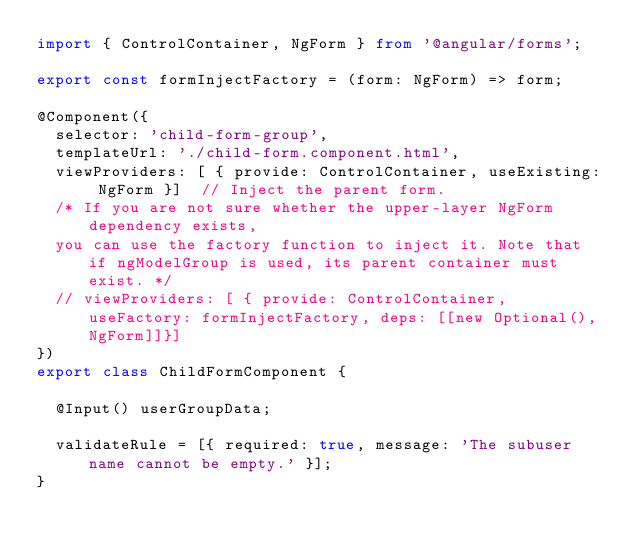<code> <loc_0><loc_0><loc_500><loc_500><_TypeScript_>import { ControlContainer, NgForm } from '@angular/forms';

export const formInjectFactory = (form: NgForm) => form;

@Component({
  selector: 'child-form-group',
  templateUrl: './child-form.component.html',
  viewProviders: [ { provide: ControlContainer, useExisting: NgForm }]  // Inject the parent form.
  /* If you are not sure whether the upper-layer NgForm dependency exists,
  you can use the factory function to inject it. Note that if ngModelGroup is used, its parent container must exist. */
  // viewProviders: [ { provide: ControlContainer, useFactory: formInjectFactory, deps: [[new Optional(), NgForm]]}]
})
export class ChildFormComponent {

  @Input() userGroupData;

  validateRule = [{ required: true, message: 'The subuser name cannot be empty.' }];
}
</code> 